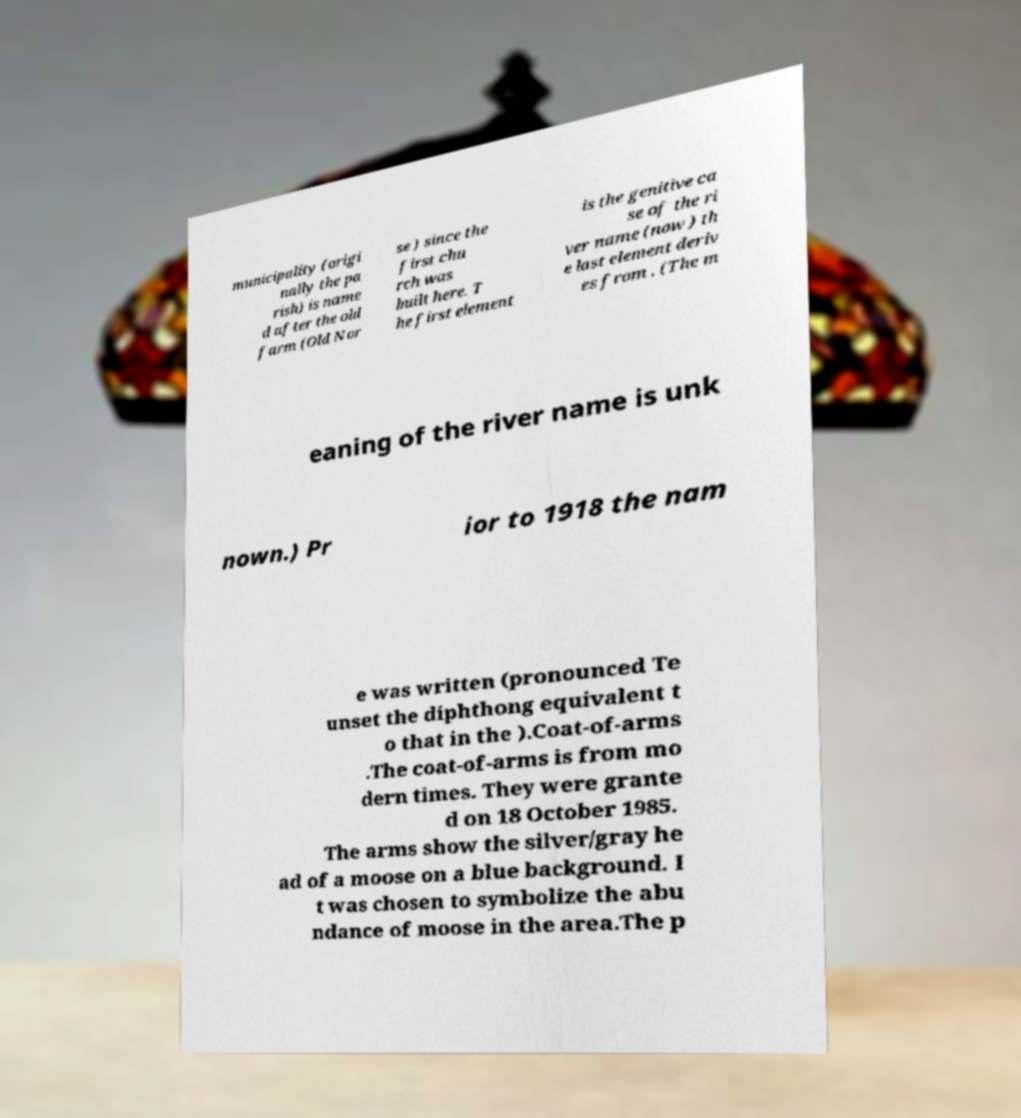Could you assist in decoding the text presented in this image and type it out clearly? municipality (origi nally the pa rish) is name d after the old farm (Old Nor se ) since the first chu rch was built here. T he first element is the genitive ca se of the ri ver name (now ) th e last element deriv es from . (The m eaning of the river name is unk nown.) Pr ior to 1918 the nam e was written (pronounced Te unset the diphthong equivalent t o that in the ).Coat-of-arms .The coat-of-arms is from mo dern times. They were grante d on 18 October 1985. The arms show the silver/gray he ad of a moose on a blue background. I t was chosen to symbolize the abu ndance of moose in the area.The p 